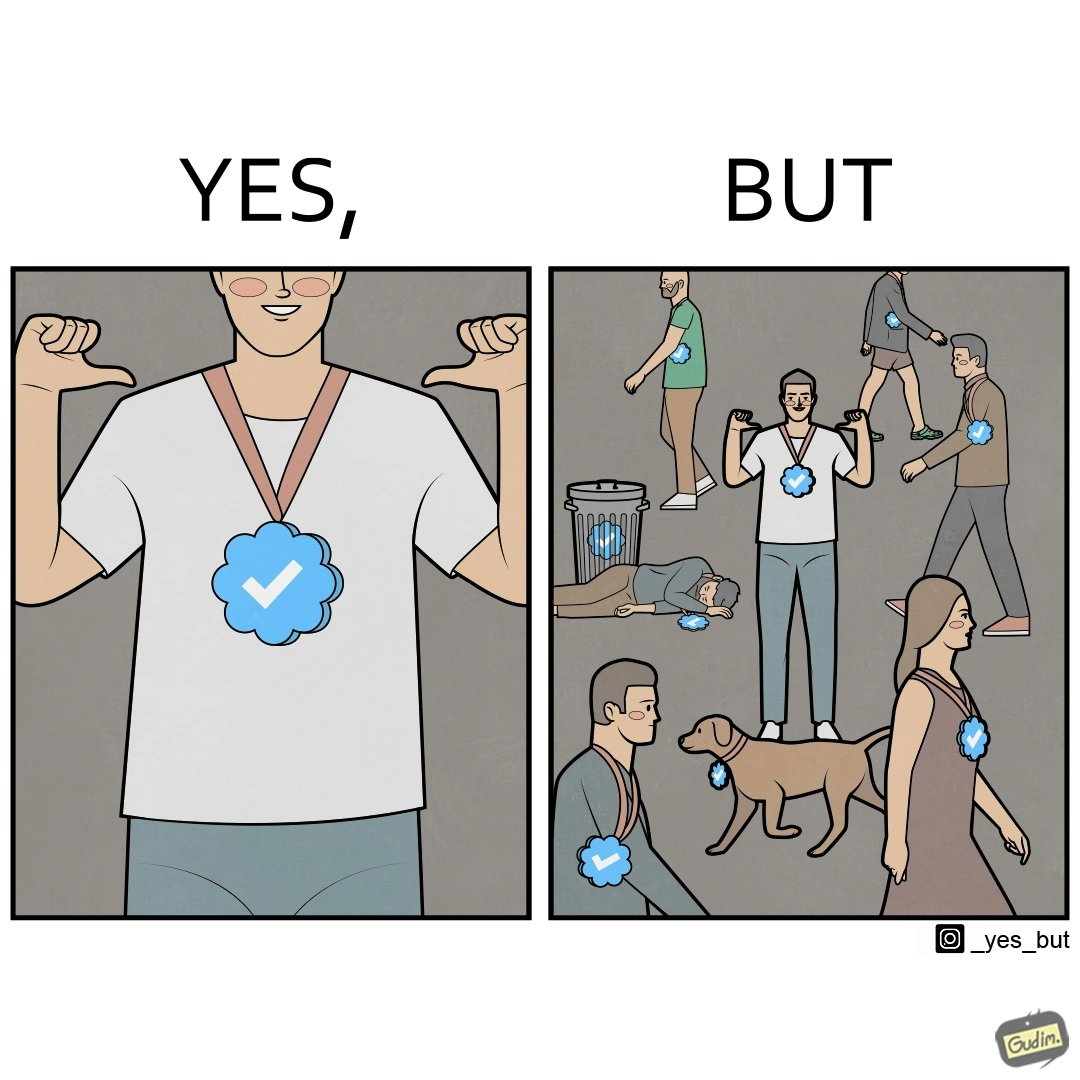Provide a description of this image. The images are funny since they show a man who thinks he has made a great achievement by winning a medal and is proud while everyone around him has the same medal and have achieved the same thing as he has 